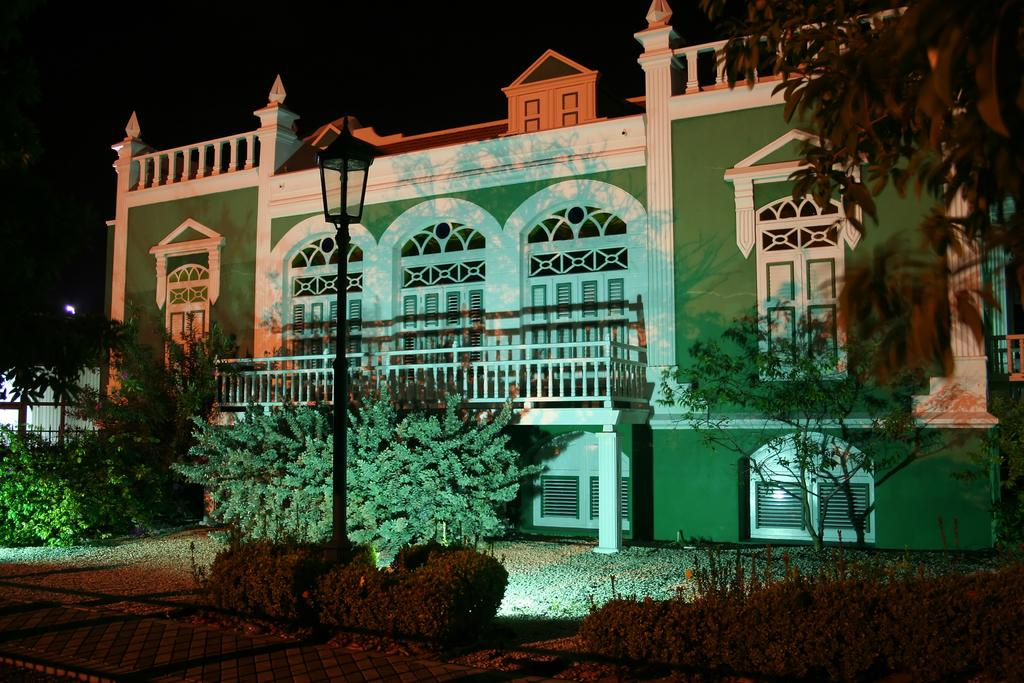What type of surface is visible in the image? There is a pavement in the image. What can be seen beside the pavement? There are plants beside the pavement. What type of natural environment is present in the image? There is a grassland in the image. What structure can be seen in the image? There is a light pole in the image. What is visible in the background of the image? There is a house in the background of the image. Can you tell me what type of horn is being played in the image? There is no horn present in the image. Is there a doctor attending to someone in the image? There is no doctor or any medical situation depicted in the image. 